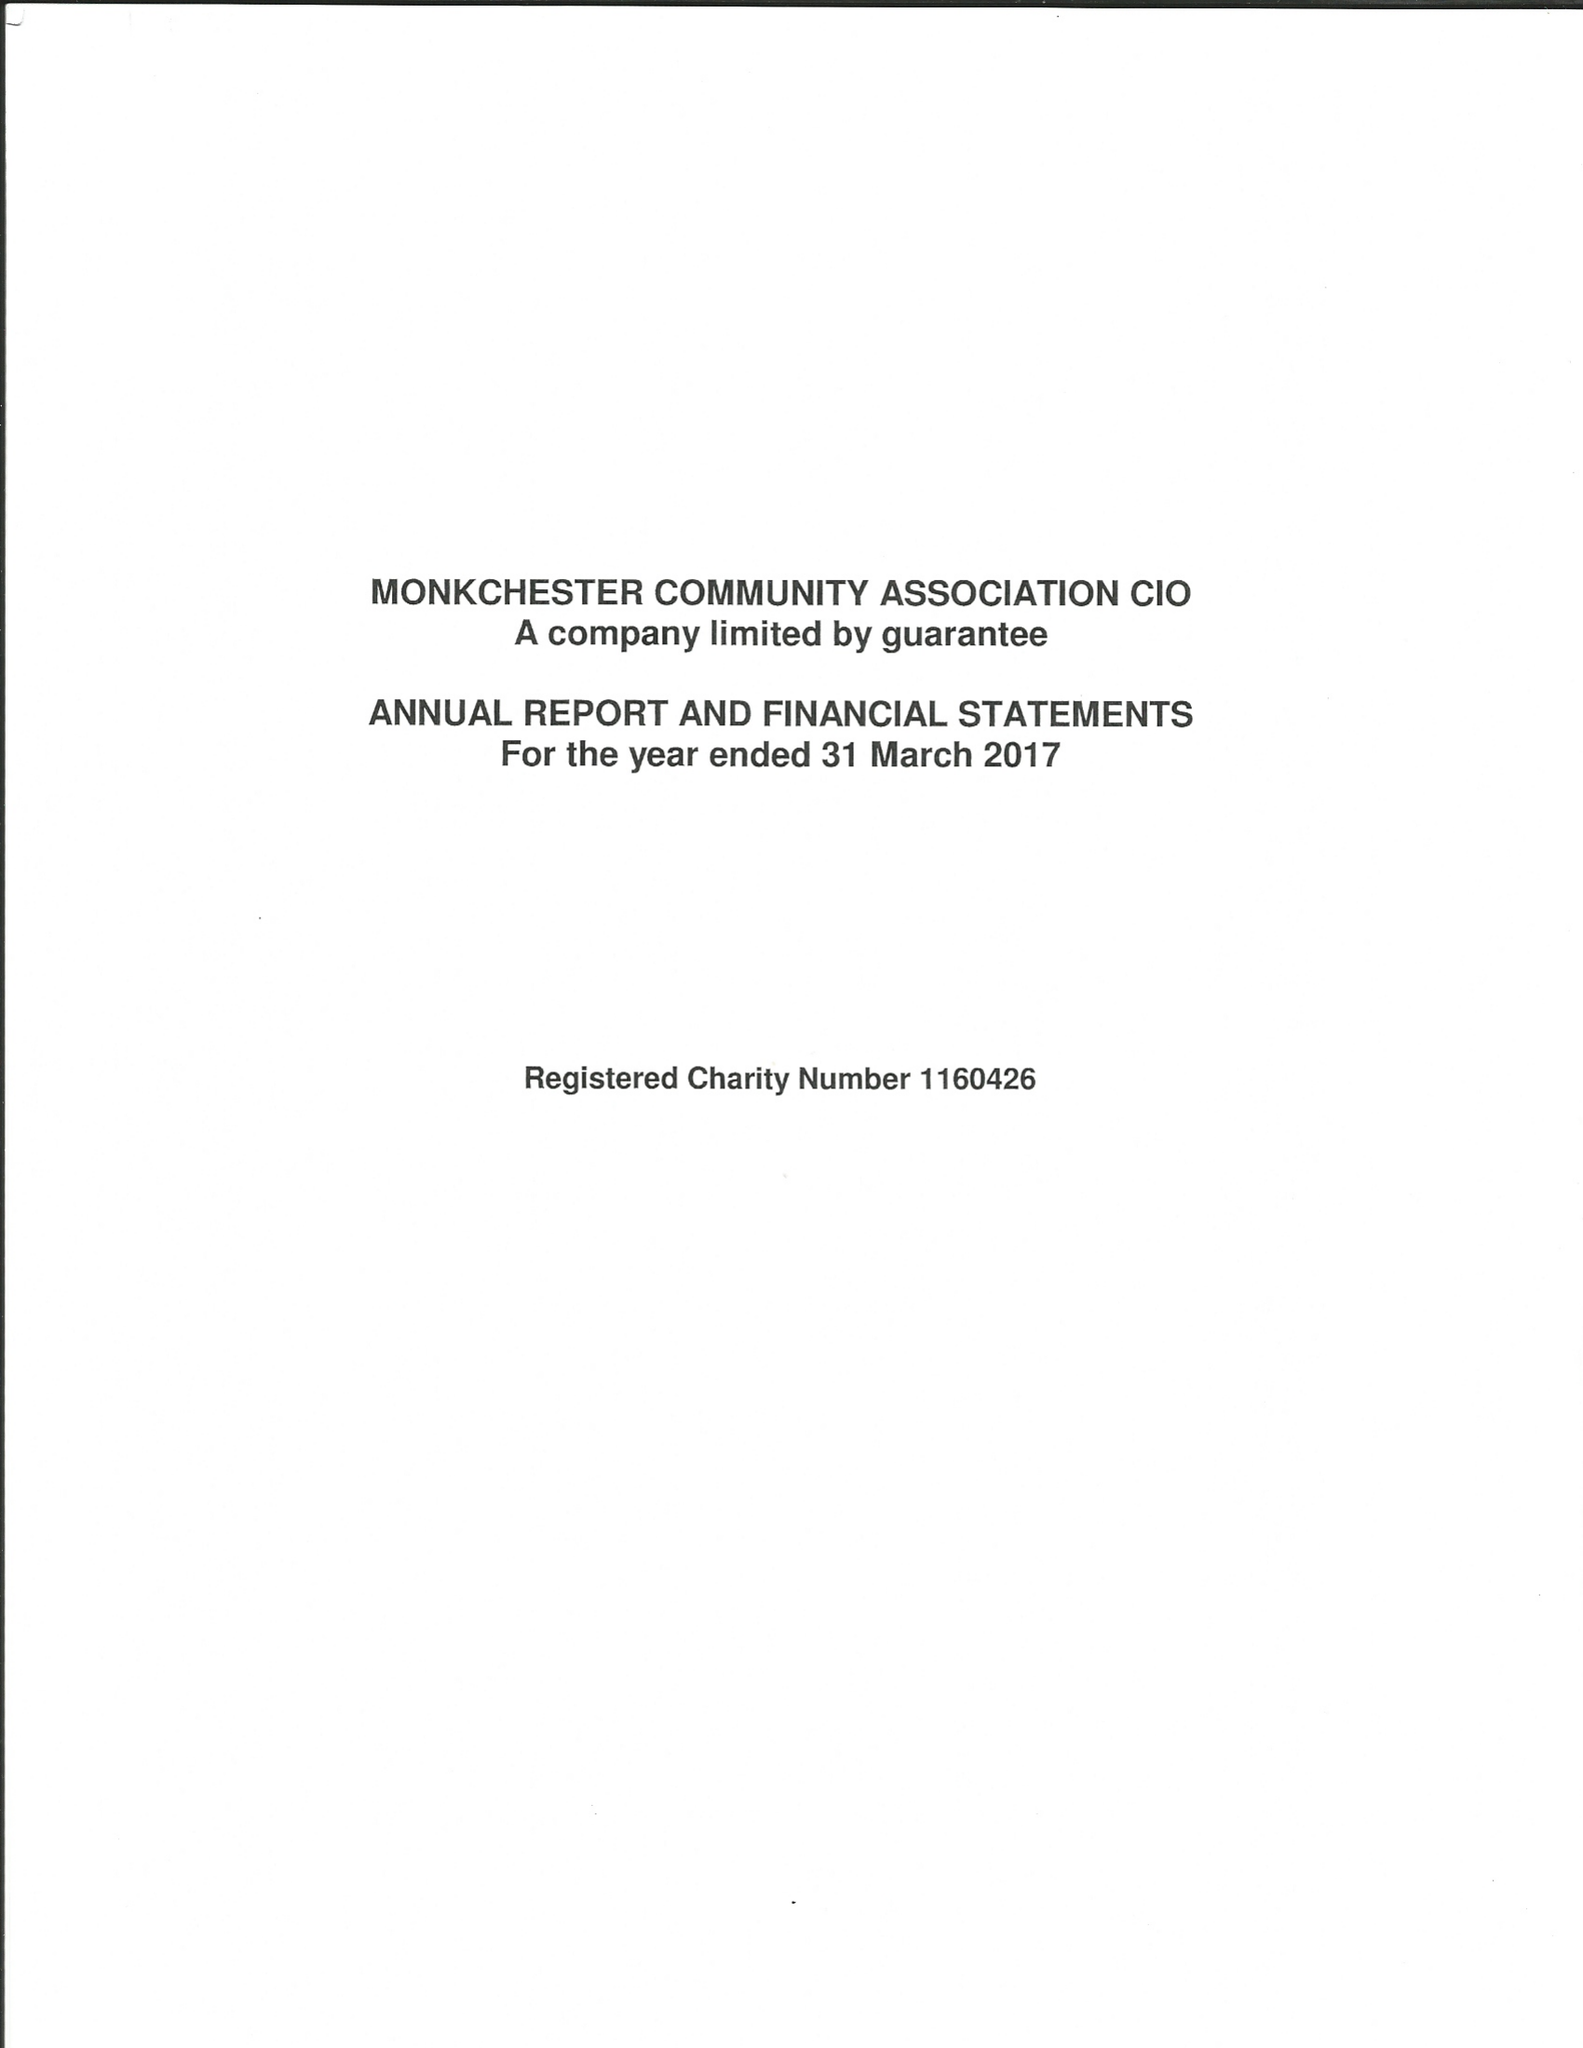What is the value for the report_date?
Answer the question using a single word or phrase. 2017-03-31 